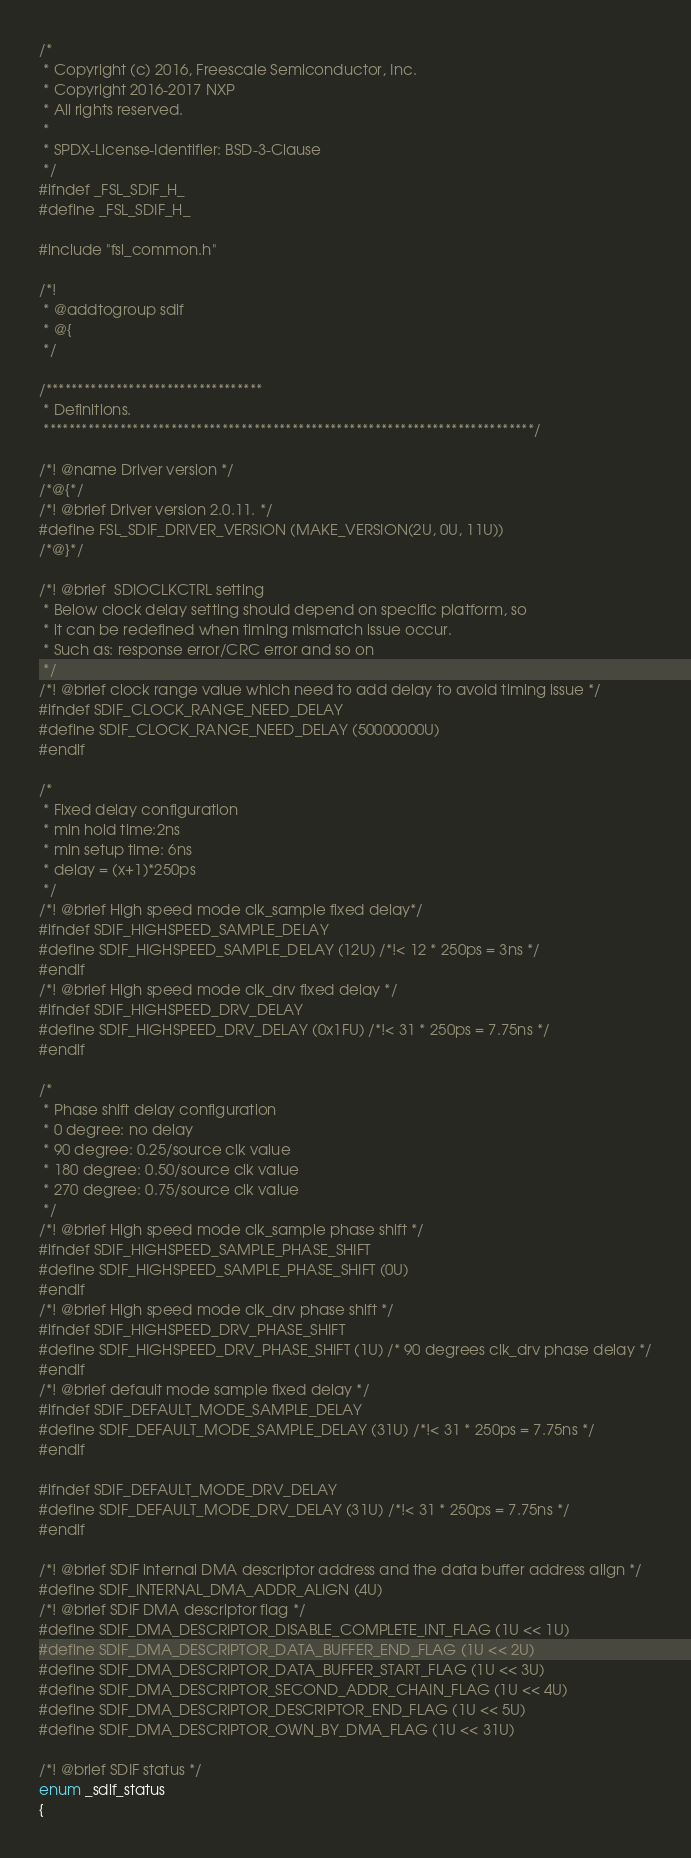Convert code to text. <code><loc_0><loc_0><loc_500><loc_500><_C_>/*
 * Copyright (c) 2016, Freescale Semiconductor, Inc.
 * Copyright 2016-2017 NXP
 * All rights reserved.
 *
 * SPDX-License-Identifier: BSD-3-Clause
 */
#ifndef _FSL_SDIF_H_
#define _FSL_SDIF_H_

#include "fsl_common.h"

/*!
 * @addtogroup sdif
 * @{
 */

/**********************************
 * Definitions.
 *****************************************************************************/

/*! @name Driver version */
/*@{*/
/*! @brief Driver version 2.0.11. */
#define FSL_SDIF_DRIVER_VERSION (MAKE_VERSION(2U, 0U, 11U))
/*@}*/

/*! @brief  SDIOCLKCTRL setting
 * Below clock delay setting should depend on specific platform, so
 * it can be redefined when timing mismatch issue occur.
 * Such as: response error/CRC error and so on
 */
/*! @brief clock range value which need to add delay to avoid timing issue */
#ifndef SDIF_CLOCK_RANGE_NEED_DELAY
#define SDIF_CLOCK_RANGE_NEED_DELAY (50000000U)
#endif

/*
 * Fixed delay configuration
 * min hold time:2ns
 * min setup time: 6ns
 * delay = (x+1)*250ps
 */
/*! @brief High speed mode clk_sample fixed delay*/
#ifndef SDIF_HIGHSPEED_SAMPLE_DELAY
#define SDIF_HIGHSPEED_SAMPLE_DELAY (12U) /*!< 12 * 250ps = 3ns */
#endif
/*! @brief High speed mode clk_drv fixed delay */
#ifndef SDIF_HIGHSPEED_DRV_DELAY
#define SDIF_HIGHSPEED_DRV_DELAY (0x1FU) /*!< 31 * 250ps = 7.75ns */
#endif

/*
 * Phase shift delay configuration
 * 0 degree: no delay
 * 90 degree: 0.25/source clk value
 * 180 degree: 0.50/source clk value
 * 270 degree: 0.75/source clk value
 */
/*! @brief High speed mode clk_sample phase shift */
#ifndef SDIF_HIGHSPEED_SAMPLE_PHASE_SHIFT
#define SDIF_HIGHSPEED_SAMPLE_PHASE_SHIFT (0U)
#endif
/*! @brief High speed mode clk_drv phase shift */
#ifndef SDIF_HIGHSPEED_DRV_PHASE_SHIFT
#define SDIF_HIGHSPEED_DRV_PHASE_SHIFT (1U) /* 90 degrees clk_drv phase delay */
#endif
/*! @brief default mode sample fixed delay */
#ifndef SDIF_DEFAULT_MODE_SAMPLE_DELAY
#define SDIF_DEFAULT_MODE_SAMPLE_DELAY (31U) /*!< 31 * 250ps = 7.75ns */
#endif

#ifndef SDIF_DEFAULT_MODE_DRV_DELAY
#define SDIF_DEFAULT_MODE_DRV_DELAY (31U) /*!< 31 * 250ps = 7.75ns */
#endif

/*! @brief SDIF internal DMA descriptor address and the data buffer address align */
#define SDIF_INTERNAL_DMA_ADDR_ALIGN (4U)
/*! @brief SDIF DMA descriptor flag */
#define SDIF_DMA_DESCRIPTOR_DISABLE_COMPLETE_INT_FLAG (1U << 1U)
#define SDIF_DMA_DESCRIPTOR_DATA_BUFFER_END_FLAG (1U << 2U)
#define SDIF_DMA_DESCRIPTOR_DATA_BUFFER_START_FLAG (1U << 3U)
#define SDIF_DMA_DESCRIPTOR_SECOND_ADDR_CHAIN_FLAG (1U << 4U)
#define SDIF_DMA_DESCRIPTOR_DESCRIPTOR_END_FLAG (1U << 5U)
#define SDIF_DMA_DESCRIPTOR_OWN_BY_DMA_FLAG (1U << 31U)

/*! @brief SDIF status */
enum _sdif_status
{</code> 